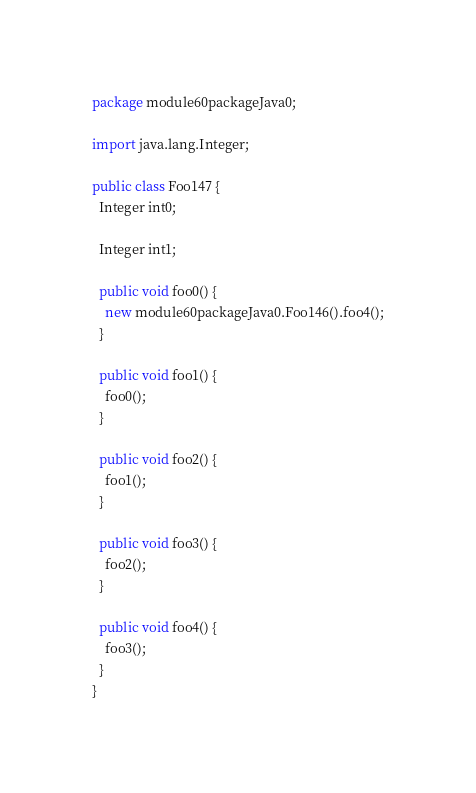Convert code to text. <code><loc_0><loc_0><loc_500><loc_500><_Java_>package module60packageJava0;

import java.lang.Integer;

public class Foo147 {
  Integer int0;

  Integer int1;

  public void foo0() {
    new module60packageJava0.Foo146().foo4();
  }

  public void foo1() {
    foo0();
  }

  public void foo2() {
    foo1();
  }

  public void foo3() {
    foo2();
  }

  public void foo4() {
    foo3();
  }
}
</code> 